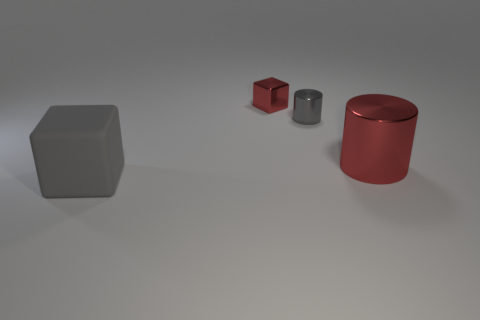Add 1 large red cylinders. How many objects exist? 5 Add 4 small blue matte cylinders. How many small blue matte cylinders exist? 4 Subtract 0 red balls. How many objects are left? 4 Subtract all tiny yellow cylinders. Subtract all rubber things. How many objects are left? 3 Add 3 red things. How many red things are left? 5 